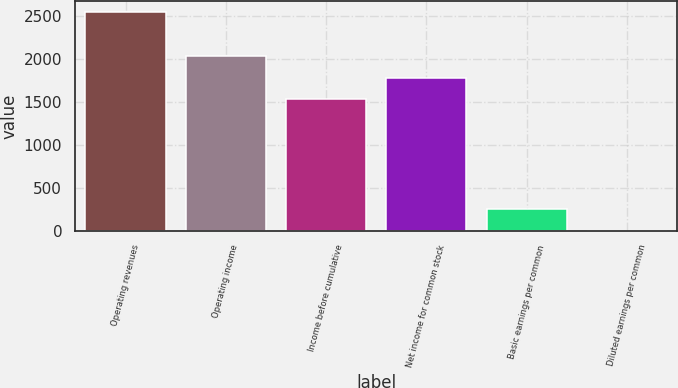Convert chart. <chart><loc_0><loc_0><loc_500><loc_500><bar_chart><fcel>Operating revenues<fcel>Operating income<fcel>Income before cumulative<fcel>Net income for common stock<fcel>Basic earnings per common<fcel>Diluted earnings per common<nl><fcel>2539.5<fcel>2031.86<fcel>1524.22<fcel>1778.04<fcel>255.12<fcel>1.3<nl></chart> 